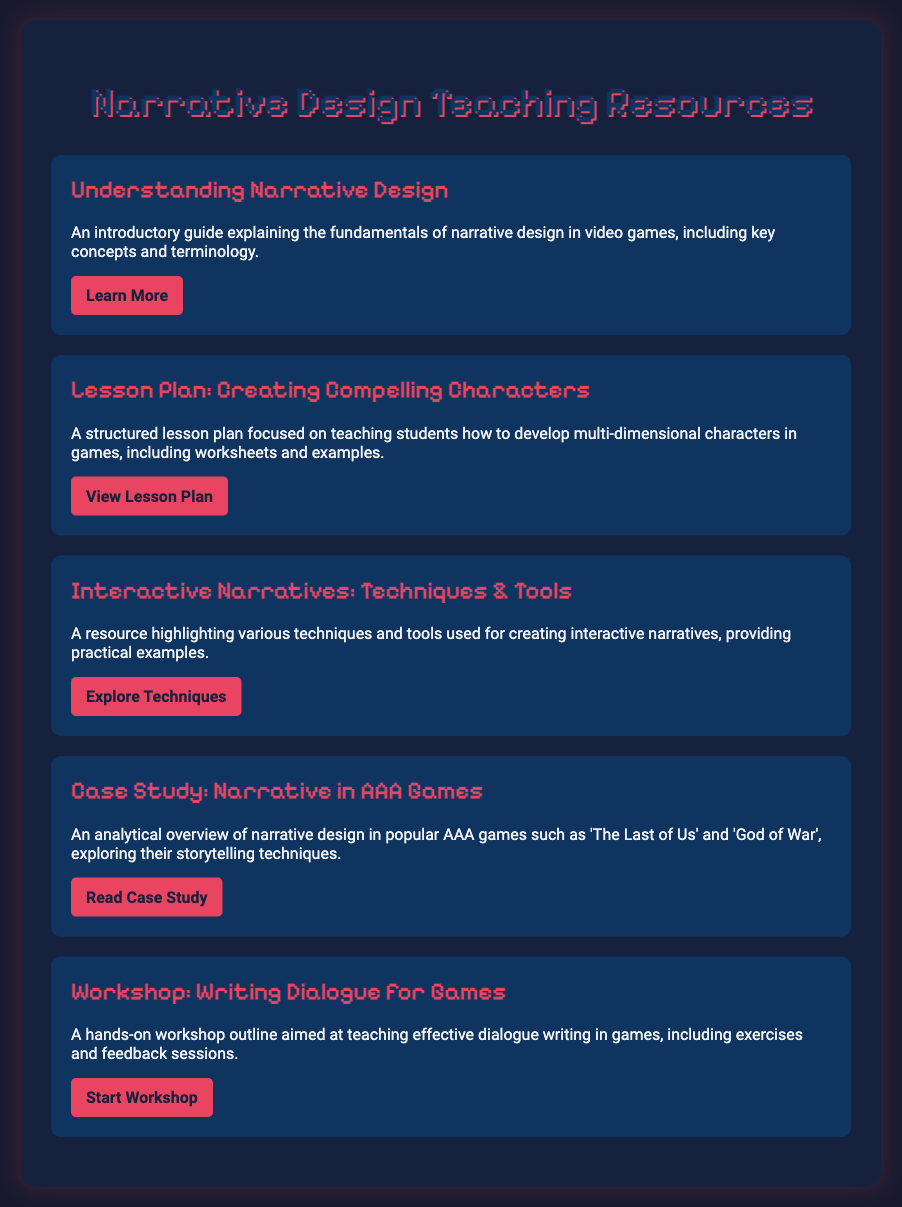what is the title of the first menu item? The title of the first menu item is the main subject mentioned prominently at the top, which is "Understanding Narrative Design."
Answer: Understanding Narrative Design how many resources are listed in the document? The document contains five menu items, each representing a distinct resource related to narrative design.
Answer: 5 which lesson plan is focused on character development? The lesson plan that focuses on character development is clearly specified by its title, "Lesson Plan: Creating Compelling Characters."
Answer: Creating Compelling Characters what is the primary focus of the workshop described in the document? The primary focus is indicated in the title of the workshop, which is "Writing Dialogue for Games."
Answer: Writing Dialogue for Games which case study is mentioned in the document? The case study mentioned in the document is related to popular AAA games, specifically "Narrative in AAA Games."
Answer: Narrative in AAA Games which resource includes hands-on exercises? The resource that includes hands-on exercises is the workshop titled "Writing Dialogue for Games."
Answer: Writing Dialogue for Games what type of narratives does the resource "Interactive Narratives: Techniques & Tools" discuss? The resource discusses interactive narratives, as specified in its title.
Answer: Interactive Narratives what is the purpose of the resource "Understanding Narrative Design"? The purpose is an introductory guide explaining the fundamentals of narrative design in video games.
Answer: An introductory guide what type of document is presented here? The document is structured as a menu of teaching resources, fulfilling an educational purpose.
Answer: Menu of teaching resources 